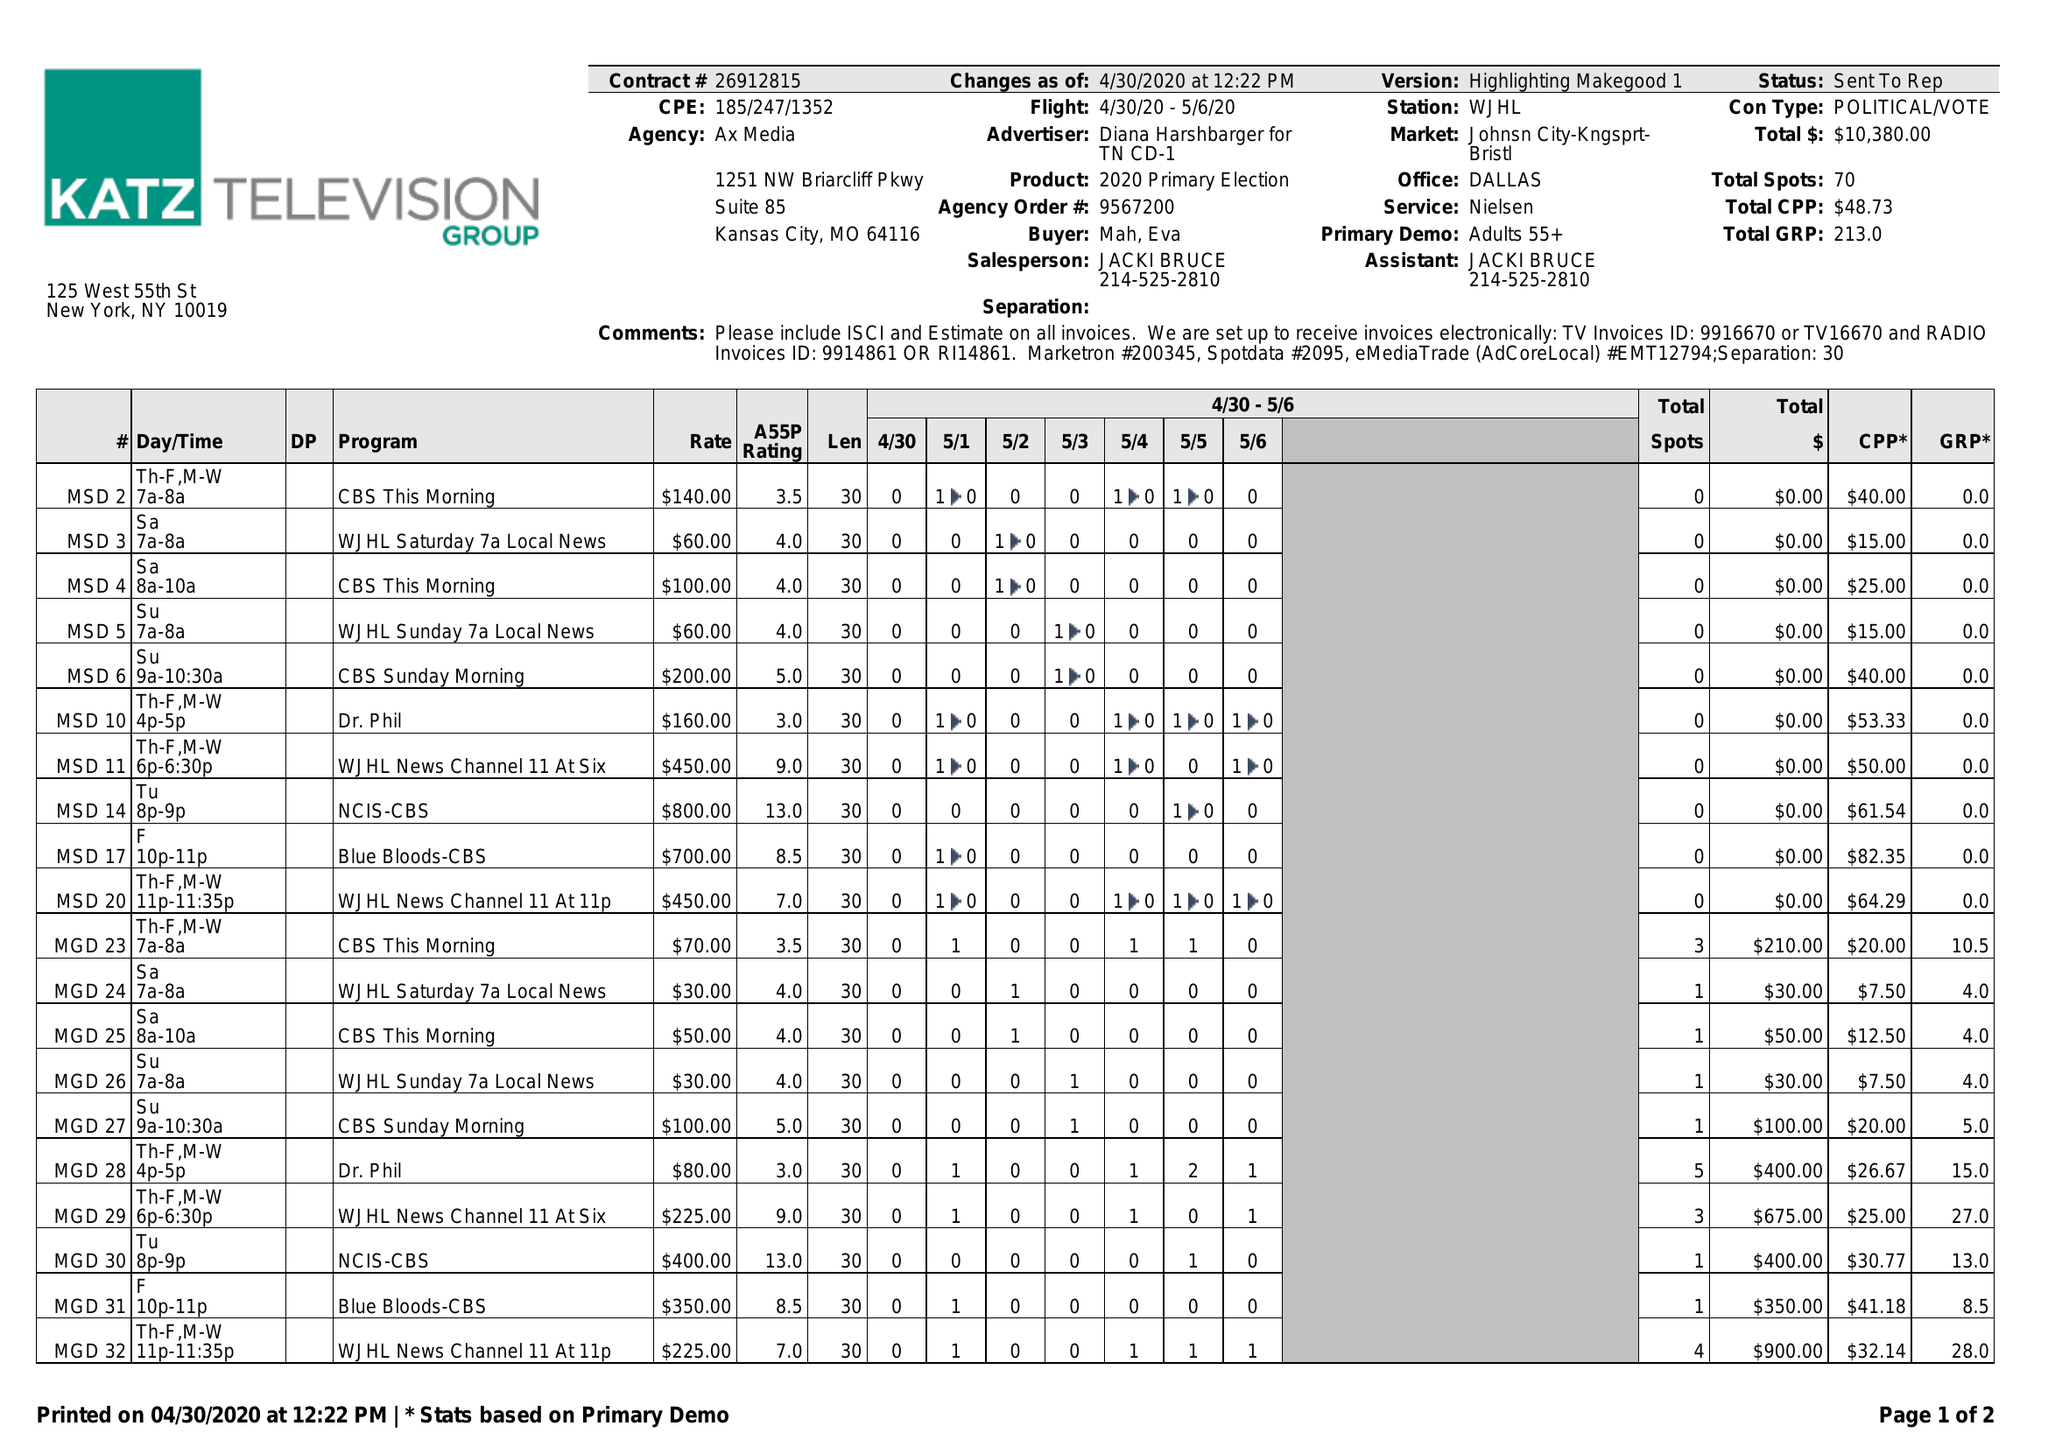What is the value for the advertiser?
Answer the question using a single word or phrase. DIANA HARSHBARGER FOR TN CD-1 